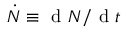Convert formula to latex. <formula><loc_0><loc_0><loc_500><loc_500>\dot { N } \equiv d N / d t</formula> 